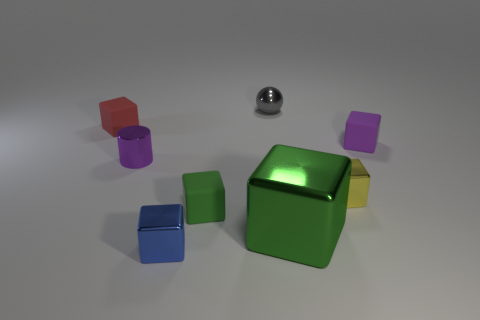Subtract 3 blocks. How many blocks are left? 3 Subtract all purple cubes. How many cubes are left? 5 Subtract all red cubes. How many cubes are left? 5 Subtract all gray cubes. Subtract all brown spheres. How many cubes are left? 6 Add 1 small blue blocks. How many objects exist? 9 Subtract all blocks. How many objects are left? 2 Subtract all things. Subtract all large matte spheres. How many objects are left? 0 Add 3 tiny purple matte cubes. How many tiny purple matte cubes are left? 4 Add 7 gray things. How many gray things exist? 8 Subtract 0 cyan cylinders. How many objects are left? 8 